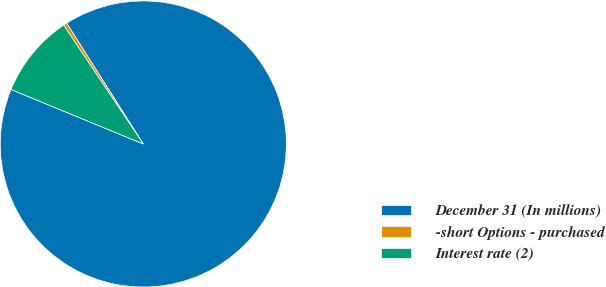Convert chart to OTSL. <chart><loc_0><loc_0><loc_500><loc_500><pie_chart><fcel>December 31 (In millions)<fcel>-short Options - purchased<fcel>Interest rate (2)<nl><fcel>90.21%<fcel>0.4%<fcel>9.38%<nl></chart> 